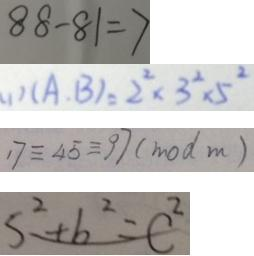Convert formula to latex. <formula><loc_0><loc_0><loc_500><loc_500>8 8 - 8 1 = 7 
 ( 1 ) ( A , B ) = 2 ^ { 2 } \times 3 ^ { 3 } \times 5 ^ { 2 } 
 1 7 \equiv 4 5 \equiv 9 7 ( m o d m ) 
 S ^ { 2 } + b ^ { 2 } = C ^ { 2 }</formula> 